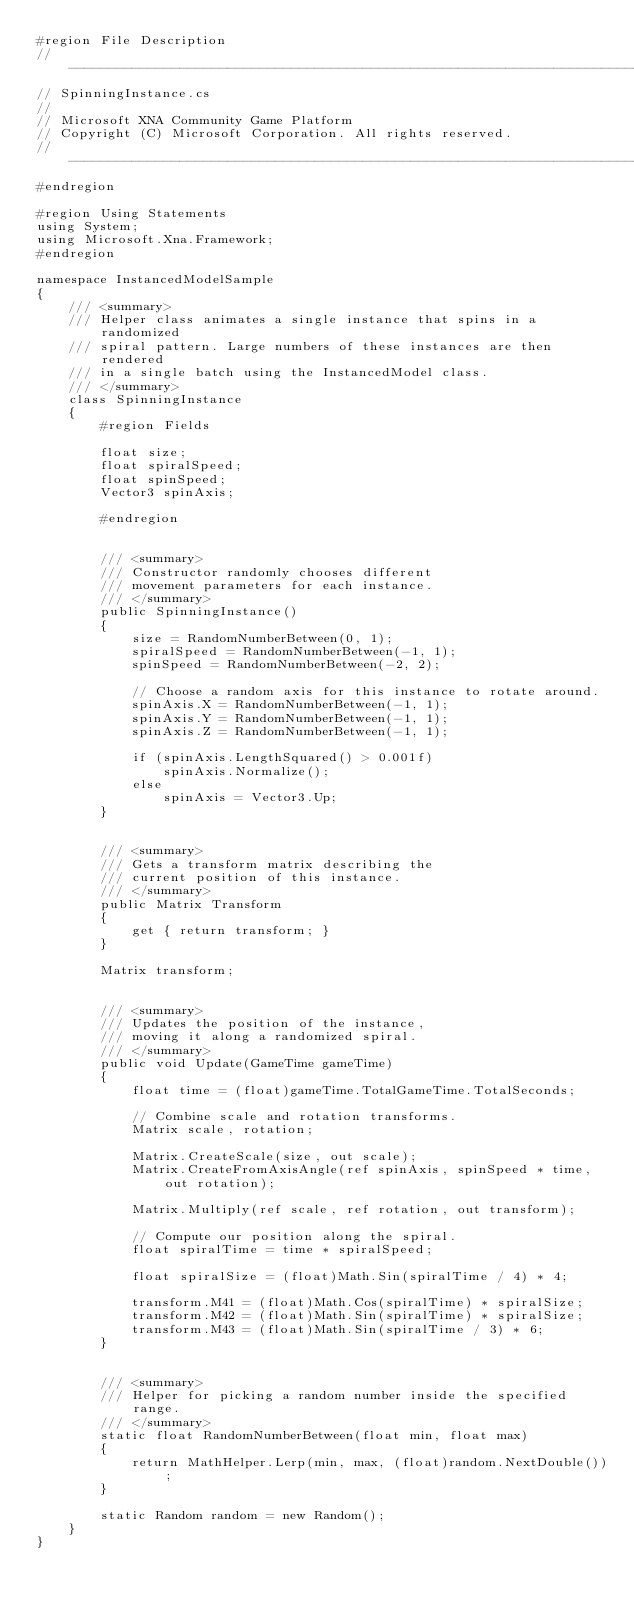<code> <loc_0><loc_0><loc_500><loc_500><_C#_>#region File Description
//-----------------------------------------------------------------------------
// SpinningInstance.cs
//
// Microsoft XNA Community Game Platform
// Copyright (C) Microsoft Corporation. All rights reserved.
//-----------------------------------------------------------------------------
#endregion

#region Using Statements
using System;
using Microsoft.Xna.Framework;
#endregion

namespace InstancedModelSample
{
    /// <summary>
    /// Helper class animates a single instance that spins in a randomized
    /// spiral pattern. Large numbers of these instances are then rendered
    /// in a single batch using the InstancedModel class.
    /// </summary>
    class SpinningInstance
    {
        #region Fields

        float size;
        float spiralSpeed;
        float spinSpeed;
        Vector3 spinAxis;

        #endregion


        /// <summary>
        /// Constructor randomly chooses different
        /// movement parameters for each instance.
        /// </summary>
        public SpinningInstance()
        {
            size = RandomNumberBetween(0, 1);
            spiralSpeed = RandomNumberBetween(-1, 1);
            spinSpeed = RandomNumberBetween(-2, 2);

            // Choose a random axis for this instance to rotate around.
            spinAxis.X = RandomNumberBetween(-1, 1);
            spinAxis.Y = RandomNumberBetween(-1, 1);
            spinAxis.Z = RandomNumberBetween(-1, 1);

            if (spinAxis.LengthSquared() > 0.001f)
                spinAxis.Normalize();
            else
                spinAxis = Vector3.Up;
        }


        /// <summary>
        /// Gets a transform matrix describing the
        /// current position of this instance.
        /// </summary>
        public Matrix Transform
        {
            get { return transform; }
        }

        Matrix transform;


        /// <summary>
        /// Updates the position of the instance,
        /// moving it along a randomized spiral.
        /// </summary>
        public void Update(GameTime gameTime)
        {
            float time = (float)gameTime.TotalGameTime.TotalSeconds;

            // Combine scale and rotation transforms.
            Matrix scale, rotation;

            Matrix.CreateScale(size, out scale);
            Matrix.CreateFromAxisAngle(ref spinAxis, spinSpeed * time, out rotation);

            Matrix.Multiply(ref scale, ref rotation, out transform);

            // Compute our position along the spiral.
            float spiralTime = time * spiralSpeed;

            float spiralSize = (float)Math.Sin(spiralTime / 4) * 4;

            transform.M41 = (float)Math.Cos(spiralTime) * spiralSize;
            transform.M42 = (float)Math.Sin(spiralTime) * spiralSize;
            transform.M43 = (float)Math.Sin(spiralTime / 3) * 6;
        }


        /// <summary>
        /// Helper for picking a random number inside the specified range.
        /// </summary>
        static float RandomNumberBetween(float min, float max)
        {
            return MathHelper.Lerp(min, max, (float)random.NextDouble());
        }

        static Random random = new Random();
    }
}
</code> 